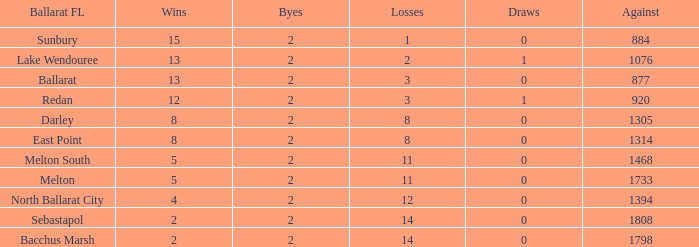How many losses are there in a ballarat fl of melton south, with a confrontation exceeding 1468? 0.0. 